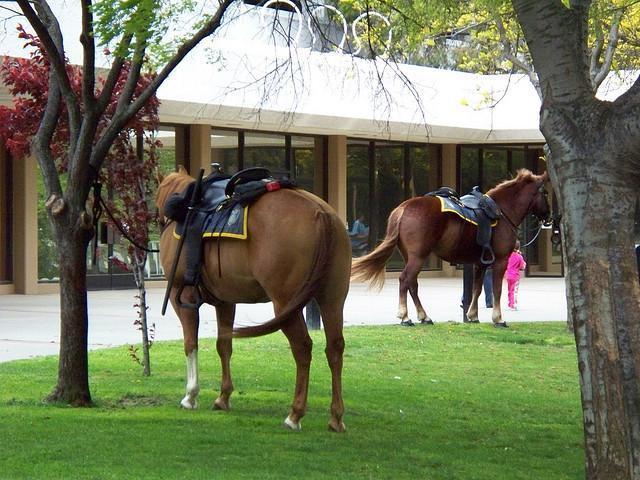How many trees are in the grass?
Give a very brief answer. 3. How many horses are there?
Give a very brief answer. 2. 